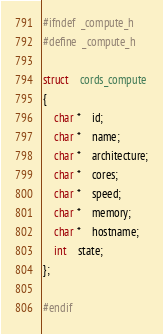<code> <loc_0><loc_0><loc_500><loc_500><_C_>#ifndef	_compute_h
#define	_compute_h

struct	cords_compute
{
	char *	id;
	char *	name;
	char *	architecture;
	char *	cores;
	char *	speed;
	char *	memory;
	char *	hostname;
	int	state;
};

#endif

</code> 